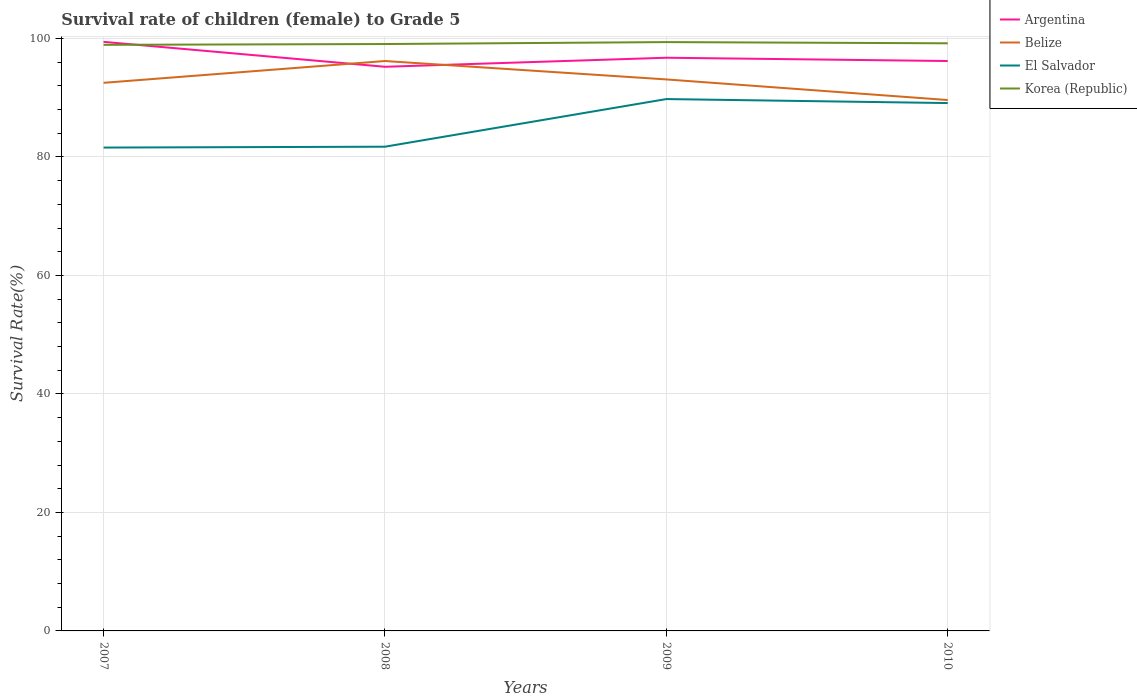How many different coloured lines are there?
Your response must be concise. 4. Does the line corresponding to El Salvador intersect with the line corresponding to Argentina?
Offer a terse response. No. Is the number of lines equal to the number of legend labels?
Keep it short and to the point. Yes. Across all years, what is the maximum survival rate of female children to grade 5 in Argentina?
Keep it short and to the point. 95.22. In which year was the survival rate of female children to grade 5 in Argentina maximum?
Give a very brief answer. 2008. What is the total survival rate of female children to grade 5 in El Salvador in the graph?
Keep it short and to the point. -8.19. What is the difference between the highest and the second highest survival rate of female children to grade 5 in Korea (Republic)?
Your answer should be very brief. 0.46. What is the difference between the highest and the lowest survival rate of female children to grade 5 in Argentina?
Your answer should be compact. 1. Is the survival rate of female children to grade 5 in Korea (Republic) strictly greater than the survival rate of female children to grade 5 in El Salvador over the years?
Provide a succinct answer. No. Are the values on the major ticks of Y-axis written in scientific E-notation?
Make the answer very short. No. How many legend labels are there?
Your response must be concise. 4. How are the legend labels stacked?
Provide a succinct answer. Vertical. What is the title of the graph?
Your response must be concise. Survival rate of children (female) to Grade 5. What is the label or title of the Y-axis?
Your response must be concise. Survival Rate(%). What is the Survival Rate(%) in Argentina in 2007?
Your answer should be very brief. 99.43. What is the Survival Rate(%) in Belize in 2007?
Keep it short and to the point. 92.51. What is the Survival Rate(%) of El Salvador in 2007?
Offer a terse response. 81.59. What is the Survival Rate(%) of Korea (Republic) in 2007?
Offer a terse response. 98.93. What is the Survival Rate(%) of Argentina in 2008?
Your answer should be very brief. 95.22. What is the Survival Rate(%) of Belize in 2008?
Keep it short and to the point. 96.19. What is the Survival Rate(%) of El Salvador in 2008?
Your response must be concise. 81.73. What is the Survival Rate(%) in Korea (Republic) in 2008?
Offer a terse response. 99.06. What is the Survival Rate(%) in Argentina in 2009?
Provide a short and direct response. 96.75. What is the Survival Rate(%) of Belize in 2009?
Your response must be concise. 93.09. What is the Survival Rate(%) in El Salvador in 2009?
Give a very brief answer. 89.77. What is the Survival Rate(%) in Korea (Republic) in 2009?
Offer a terse response. 99.39. What is the Survival Rate(%) in Argentina in 2010?
Offer a very short reply. 96.19. What is the Survival Rate(%) of Belize in 2010?
Provide a succinct answer. 89.61. What is the Survival Rate(%) of El Salvador in 2010?
Keep it short and to the point. 89.1. What is the Survival Rate(%) of Korea (Republic) in 2010?
Provide a succinct answer. 99.18. Across all years, what is the maximum Survival Rate(%) of Argentina?
Keep it short and to the point. 99.43. Across all years, what is the maximum Survival Rate(%) of Belize?
Offer a terse response. 96.19. Across all years, what is the maximum Survival Rate(%) in El Salvador?
Your answer should be compact. 89.77. Across all years, what is the maximum Survival Rate(%) in Korea (Republic)?
Your answer should be compact. 99.39. Across all years, what is the minimum Survival Rate(%) of Argentina?
Provide a succinct answer. 95.22. Across all years, what is the minimum Survival Rate(%) of Belize?
Provide a short and direct response. 89.61. Across all years, what is the minimum Survival Rate(%) in El Salvador?
Offer a very short reply. 81.59. Across all years, what is the minimum Survival Rate(%) of Korea (Republic)?
Your response must be concise. 98.93. What is the total Survival Rate(%) in Argentina in the graph?
Give a very brief answer. 387.59. What is the total Survival Rate(%) in Belize in the graph?
Provide a succinct answer. 371.41. What is the total Survival Rate(%) of El Salvador in the graph?
Provide a short and direct response. 342.19. What is the total Survival Rate(%) in Korea (Republic) in the graph?
Your response must be concise. 396.56. What is the difference between the Survival Rate(%) of Argentina in 2007 and that in 2008?
Provide a short and direct response. 4.21. What is the difference between the Survival Rate(%) of Belize in 2007 and that in 2008?
Provide a succinct answer. -3.68. What is the difference between the Survival Rate(%) of El Salvador in 2007 and that in 2008?
Make the answer very short. -0.15. What is the difference between the Survival Rate(%) of Korea (Republic) in 2007 and that in 2008?
Make the answer very short. -0.13. What is the difference between the Survival Rate(%) of Argentina in 2007 and that in 2009?
Offer a terse response. 2.68. What is the difference between the Survival Rate(%) in Belize in 2007 and that in 2009?
Keep it short and to the point. -0.57. What is the difference between the Survival Rate(%) in El Salvador in 2007 and that in 2009?
Provide a short and direct response. -8.19. What is the difference between the Survival Rate(%) of Korea (Republic) in 2007 and that in 2009?
Your answer should be compact. -0.46. What is the difference between the Survival Rate(%) of Argentina in 2007 and that in 2010?
Provide a short and direct response. 3.23. What is the difference between the Survival Rate(%) in Belize in 2007 and that in 2010?
Ensure brevity in your answer.  2.91. What is the difference between the Survival Rate(%) of El Salvador in 2007 and that in 2010?
Offer a terse response. -7.51. What is the difference between the Survival Rate(%) of Korea (Republic) in 2007 and that in 2010?
Keep it short and to the point. -0.26. What is the difference between the Survival Rate(%) in Argentina in 2008 and that in 2009?
Your answer should be compact. -1.53. What is the difference between the Survival Rate(%) of Belize in 2008 and that in 2009?
Keep it short and to the point. 3.11. What is the difference between the Survival Rate(%) in El Salvador in 2008 and that in 2009?
Ensure brevity in your answer.  -8.04. What is the difference between the Survival Rate(%) in Korea (Republic) in 2008 and that in 2009?
Your response must be concise. -0.33. What is the difference between the Survival Rate(%) of Argentina in 2008 and that in 2010?
Provide a short and direct response. -0.97. What is the difference between the Survival Rate(%) in Belize in 2008 and that in 2010?
Your answer should be compact. 6.58. What is the difference between the Survival Rate(%) of El Salvador in 2008 and that in 2010?
Your answer should be very brief. -7.36. What is the difference between the Survival Rate(%) in Korea (Republic) in 2008 and that in 2010?
Ensure brevity in your answer.  -0.12. What is the difference between the Survival Rate(%) of Argentina in 2009 and that in 2010?
Your answer should be compact. 0.55. What is the difference between the Survival Rate(%) of Belize in 2009 and that in 2010?
Your answer should be very brief. 3.48. What is the difference between the Survival Rate(%) in El Salvador in 2009 and that in 2010?
Keep it short and to the point. 0.68. What is the difference between the Survival Rate(%) of Korea (Republic) in 2009 and that in 2010?
Make the answer very short. 0.2. What is the difference between the Survival Rate(%) of Argentina in 2007 and the Survival Rate(%) of Belize in 2008?
Your response must be concise. 3.23. What is the difference between the Survival Rate(%) in Argentina in 2007 and the Survival Rate(%) in El Salvador in 2008?
Offer a terse response. 17.7. What is the difference between the Survival Rate(%) in Argentina in 2007 and the Survival Rate(%) in Korea (Republic) in 2008?
Make the answer very short. 0.37. What is the difference between the Survival Rate(%) of Belize in 2007 and the Survival Rate(%) of El Salvador in 2008?
Give a very brief answer. 10.78. What is the difference between the Survival Rate(%) of Belize in 2007 and the Survival Rate(%) of Korea (Republic) in 2008?
Your response must be concise. -6.55. What is the difference between the Survival Rate(%) of El Salvador in 2007 and the Survival Rate(%) of Korea (Republic) in 2008?
Your answer should be compact. -17.47. What is the difference between the Survival Rate(%) in Argentina in 2007 and the Survival Rate(%) in Belize in 2009?
Make the answer very short. 6.34. What is the difference between the Survival Rate(%) in Argentina in 2007 and the Survival Rate(%) in El Salvador in 2009?
Your answer should be compact. 9.65. What is the difference between the Survival Rate(%) in Argentina in 2007 and the Survival Rate(%) in Korea (Republic) in 2009?
Provide a succinct answer. 0.04. What is the difference between the Survival Rate(%) of Belize in 2007 and the Survival Rate(%) of El Salvador in 2009?
Your answer should be compact. 2.74. What is the difference between the Survival Rate(%) in Belize in 2007 and the Survival Rate(%) in Korea (Republic) in 2009?
Keep it short and to the point. -6.87. What is the difference between the Survival Rate(%) in El Salvador in 2007 and the Survival Rate(%) in Korea (Republic) in 2009?
Provide a succinct answer. -17.8. What is the difference between the Survival Rate(%) of Argentina in 2007 and the Survival Rate(%) of Belize in 2010?
Your response must be concise. 9.82. What is the difference between the Survival Rate(%) in Argentina in 2007 and the Survival Rate(%) in El Salvador in 2010?
Provide a short and direct response. 10.33. What is the difference between the Survival Rate(%) of Argentina in 2007 and the Survival Rate(%) of Korea (Republic) in 2010?
Give a very brief answer. 0.24. What is the difference between the Survival Rate(%) in Belize in 2007 and the Survival Rate(%) in El Salvador in 2010?
Ensure brevity in your answer.  3.42. What is the difference between the Survival Rate(%) in Belize in 2007 and the Survival Rate(%) in Korea (Republic) in 2010?
Keep it short and to the point. -6.67. What is the difference between the Survival Rate(%) of El Salvador in 2007 and the Survival Rate(%) of Korea (Republic) in 2010?
Make the answer very short. -17.6. What is the difference between the Survival Rate(%) of Argentina in 2008 and the Survival Rate(%) of Belize in 2009?
Provide a short and direct response. 2.13. What is the difference between the Survival Rate(%) in Argentina in 2008 and the Survival Rate(%) in El Salvador in 2009?
Your answer should be compact. 5.45. What is the difference between the Survival Rate(%) of Argentina in 2008 and the Survival Rate(%) of Korea (Republic) in 2009?
Your answer should be very brief. -4.17. What is the difference between the Survival Rate(%) of Belize in 2008 and the Survival Rate(%) of El Salvador in 2009?
Offer a terse response. 6.42. What is the difference between the Survival Rate(%) in Belize in 2008 and the Survival Rate(%) in Korea (Republic) in 2009?
Make the answer very short. -3.19. What is the difference between the Survival Rate(%) in El Salvador in 2008 and the Survival Rate(%) in Korea (Republic) in 2009?
Keep it short and to the point. -17.66. What is the difference between the Survival Rate(%) in Argentina in 2008 and the Survival Rate(%) in Belize in 2010?
Offer a very short reply. 5.61. What is the difference between the Survival Rate(%) in Argentina in 2008 and the Survival Rate(%) in El Salvador in 2010?
Provide a short and direct response. 6.12. What is the difference between the Survival Rate(%) in Argentina in 2008 and the Survival Rate(%) in Korea (Republic) in 2010?
Keep it short and to the point. -3.96. What is the difference between the Survival Rate(%) in Belize in 2008 and the Survival Rate(%) in El Salvador in 2010?
Your response must be concise. 7.1. What is the difference between the Survival Rate(%) of Belize in 2008 and the Survival Rate(%) of Korea (Republic) in 2010?
Your answer should be very brief. -2.99. What is the difference between the Survival Rate(%) in El Salvador in 2008 and the Survival Rate(%) in Korea (Republic) in 2010?
Your answer should be compact. -17.45. What is the difference between the Survival Rate(%) of Argentina in 2009 and the Survival Rate(%) of Belize in 2010?
Your answer should be compact. 7.14. What is the difference between the Survival Rate(%) in Argentina in 2009 and the Survival Rate(%) in El Salvador in 2010?
Ensure brevity in your answer.  7.65. What is the difference between the Survival Rate(%) of Argentina in 2009 and the Survival Rate(%) of Korea (Republic) in 2010?
Your answer should be very brief. -2.43. What is the difference between the Survival Rate(%) in Belize in 2009 and the Survival Rate(%) in El Salvador in 2010?
Offer a terse response. 3.99. What is the difference between the Survival Rate(%) of Belize in 2009 and the Survival Rate(%) of Korea (Republic) in 2010?
Your answer should be very brief. -6.1. What is the difference between the Survival Rate(%) of El Salvador in 2009 and the Survival Rate(%) of Korea (Republic) in 2010?
Keep it short and to the point. -9.41. What is the average Survival Rate(%) of Argentina per year?
Give a very brief answer. 96.9. What is the average Survival Rate(%) of Belize per year?
Your answer should be very brief. 92.85. What is the average Survival Rate(%) of El Salvador per year?
Make the answer very short. 85.55. What is the average Survival Rate(%) of Korea (Republic) per year?
Offer a very short reply. 99.14. In the year 2007, what is the difference between the Survival Rate(%) of Argentina and Survival Rate(%) of Belize?
Offer a very short reply. 6.91. In the year 2007, what is the difference between the Survival Rate(%) in Argentina and Survival Rate(%) in El Salvador?
Your answer should be compact. 17.84. In the year 2007, what is the difference between the Survival Rate(%) of Argentina and Survival Rate(%) of Korea (Republic)?
Offer a very short reply. 0.5. In the year 2007, what is the difference between the Survival Rate(%) of Belize and Survival Rate(%) of El Salvador?
Give a very brief answer. 10.93. In the year 2007, what is the difference between the Survival Rate(%) of Belize and Survival Rate(%) of Korea (Republic)?
Ensure brevity in your answer.  -6.41. In the year 2007, what is the difference between the Survival Rate(%) of El Salvador and Survival Rate(%) of Korea (Republic)?
Your answer should be compact. -17.34. In the year 2008, what is the difference between the Survival Rate(%) of Argentina and Survival Rate(%) of Belize?
Your answer should be very brief. -0.97. In the year 2008, what is the difference between the Survival Rate(%) in Argentina and Survival Rate(%) in El Salvador?
Provide a short and direct response. 13.49. In the year 2008, what is the difference between the Survival Rate(%) of Argentina and Survival Rate(%) of Korea (Republic)?
Offer a very short reply. -3.84. In the year 2008, what is the difference between the Survival Rate(%) of Belize and Survival Rate(%) of El Salvador?
Provide a short and direct response. 14.46. In the year 2008, what is the difference between the Survival Rate(%) in Belize and Survival Rate(%) in Korea (Republic)?
Make the answer very short. -2.87. In the year 2008, what is the difference between the Survival Rate(%) of El Salvador and Survival Rate(%) of Korea (Republic)?
Give a very brief answer. -17.33. In the year 2009, what is the difference between the Survival Rate(%) in Argentina and Survival Rate(%) in Belize?
Offer a terse response. 3.66. In the year 2009, what is the difference between the Survival Rate(%) of Argentina and Survival Rate(%) of El Salvador?
Offer a terse response. 6.98. In the year 2009, what is the difference between the Survival Rate(%) in Argentina and Survival Rate(%) in Korea (Republic)?
Keep it short and to the point. -2.64. In the year 2009, what is the difference between the Survival Rate(%) of Belize and Survival Rate(%) of El Salvador?
Your response must be concise. 3.31. In the year 2009, what is the difference between the Survival Rate(%) in Belize and Survival Rate(%) in Korea (Republic)?
Offer a terse response. -6.3. In the year 2009, what is the difference between the Survival Rate(%) of El Salvador and Survival Rate(%) of Korea (Republic)?
Offer a terse response. -9.62. In the year 2010, what is the difference between the Survival Rate(%) of Argentina and Survival Rate(%) of Belize?
Offer a very short reply. 6.58. In the year 2010, what is the difference between the Survival Rate(%) of Argentina and Survival Rate(%) of El Salvador?
Provide a short and direct response. 7.1. In the year 2010, what is the difference between the Survival Rate(%) in Argentina and Survival Rate(%) in Korea (Republic)?
Your answer should be compact. -2.99. In the year 2010, what is the difference between the Survival Rate(%) in Belize and Survival Rate(%) in El Salvador?
Make the answer very short. 0.51. In the year 2010, what is the difference between the Survival Rate(%) in Belize and Survival Rate(%) in Korea (Republic)?
Your answer should be very brief. -9.57. In the year 2010, what is the difference between the Survival Rate(%) of El Salvador and Survival Rate(%) of Korea (Republic)?
Provide a short and direct response. -10.09. What is the ratio of the Survival Rate(%) of Argentina in 2007 to that in 2008?
Your answer should be very brief. 1.04. What is the ratio of the Survival Rate(%) in Belize in 2007 to that in 2008?
Your answer should be compact. 0.96. What is the ratio of the Survival Rate(%) of El Salvador in 2007 to that in 2008?
Offer a terse response. 1. What is the ratio of the Survival Rate(%) in Argentina in 2007 to that in 2009?
Offer a terse response. 1.03. What is the ratio of the Survival Rate(%) of Belize in 2007 to that in 2009?
Keep it short and to the point. 0.99. What is the ratio of the Survival Rate(%) of El Salvador in 2007 to that in 2009?
Make the answer very short. 0.91. What is the ratio of the Survival Rate(%) in Korea (Republic) in 2007 to that in 2009?
Your answer should be very brief. 1. What is the ratio of the Survival Rate(%) in Argentina in 2007 to that in 2010?
Make the answer very short. 1.03. What is the ratio of the Survival Rate(%) of Belize in 2007 to that in 2010?
Provide a short and direct response. 1.03. What is the ratio of the Survival Rate(%) in El Salvador in 2007 to that in 2010?
Ensure brevity in your answer.  0.92. What is the ratio of the Survival Rate(%) in Korea (Republic) in 2007 to that in 2010?
Your response must be concise. 1. What is the ratio of the Survival Rate(%) in Argentina in 2008 to that in 2009?
Give a very brief answer. 0.98. What is the ratio of the Survival Rate(%) in Belize in 2008 to that in 2009?
Your response must be concise. 1.03. What is the ratio of the Survival Rate(%) of El Salvador in 2008 to that in 2009?
Keep it short and to the point. 0.91. What is the ratio of the Survival Rate(%) in Korea (Republic) in 2008 to that in 2009?
Your answer should be compact. 1. What is the ratio of the Survival Rate(%) of Argentina in 2008 to that in 2010?
Your answer should be very brief. 0.99. What is the ratio of the Survival Rate(%) of Belize in 2008 to that in 2010?
Offer a very short reply. 1.07. What is the ratio of the Survival Rate(%) in El Salvador in 2008 to that in 2010?
Make the answer very short. 0.92. What is the ratio of the Survival Rate(%) of Korea (Republic) in 2008 to that in 2010?
Keep it short and to the point. 1. What is the ratio of the Survival Rate(%) of Argentina in 2009 to that in 2010?
Keep it short and to the point. 1.01. What is the ratio of the Survival Rate(%) in Belize in 2009 to that in 2010?
Your answer should be very brief. 1.04. What is the ratio of the Survival Rate(%) of El Salvador in 2009 to that in 2010?
Keep it short and to the point. 1.01. What is the difference between the highest and the second highest Survival Rate(%) of Argentina?
Your answer should be compact. 2.68. What is the difference between the highest and the second highest Survival Rate(%) of Belize?
Provide a short and direct response. 3.11. What is the difference between the highest and the second highest Survival Rate(%) in El Salvador?
Give a very brief answer. 0.68. What is the difference between the highest and the second highest Survival Rate(%) in Korea (Republic)?
Your response must be concise. 0.2. What is the difference between the highest and the lowest Survival Rate(%) in Argentina?
Provide a short and direct response. 4.21. What is the difference between the highest and the lowest Survival Rate(%) in Belize?
Your response must be concise. 6.58. What is the difference between the highest and the lowest Survival Rate(%) in El Salvador?
Ensure brevity in your answer.  8.19. What is the difference between the highest and the lowest Survival Rate(%) in Korea (Republic)?
Offer a terse response. 0.46. 